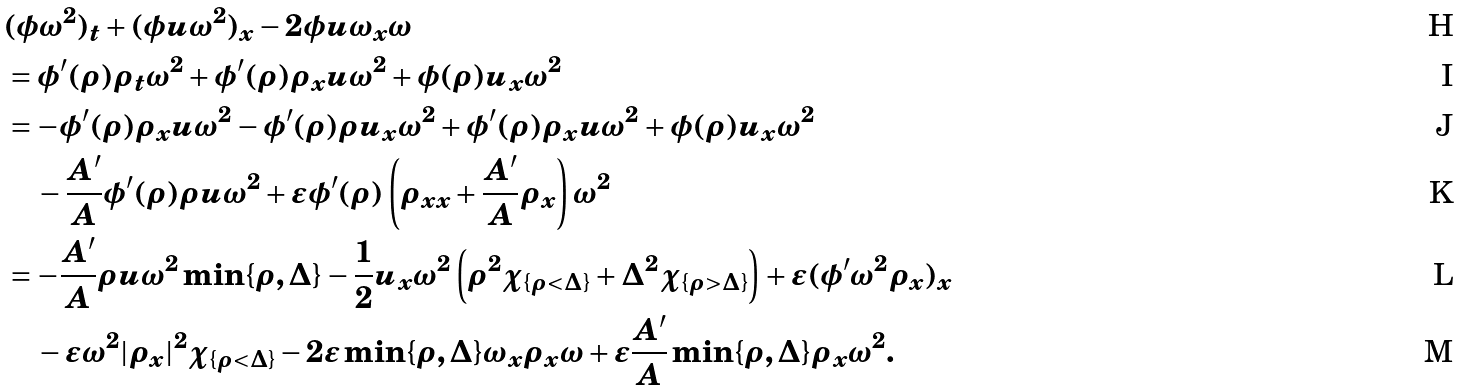<formula> <loc_0><loc_0><loc_500><loc_500>& ( \phi \omega ^ { 2 } ) _ { t } + ( \phi u \omega ^ { 2 } ) _ { x } - 2 \phi u \omega _ { x } \omega \\ & = \phi ^ { \prime } ( \rho ) \rho _ { t } \omega ^ { 2 } + \phi ^ { \prime } ( \rho ) \rho _ { x } u \omega ^ { 2 } + \phi ( \rho ) u _ { x } \omega ^ { 2 } \\ & = - \phi ^ { \prime } ( \rho ) \rho _ { x } u \omega ^ { 2 } - \phi ^ { \prime } ( \rho ) \rho u _ { x } \omega ^ { 2 } + \phi ^ { \prime } ( \rho ) \rho _ { x } u \omega ^ { 2 } + \phi ( \rho ) u _ { x } \omega ^ { 2 } \\ & \quad - \frac { A ^ { \prime } } { A } \phi ^ { \prime } ( \rho ) \rho u \omega ^ { 2 } + \varepsilon \phi ^ { \prime } ( \rho ) \left ( \rho _ { x x } + \frac { A ^ { \prime } } { A } \rho _ { x } \right ) \omega ^ { 2 } \\ & = - \frac { A ^ { \prime } } { A } \rho u \omega ^ { 2 } \min \{ \rho , \Delta \} - \frac { 1 } { 2 } u _ { x } \omega ^ { 2 } \left ( \rho ^ { 2 } \chi _ { \{ \rho < \Delta \} } + \Delta ^ { 2 } \chi _ { \{ \rho > \Delta \} } \right ) + \varepsilon ( \phi ^ { \prime } \omega ^ { 2 } \rho _ { x } ) _ { x } \\ & \quad - \varepsilon \omega ^ { 2 } | \rho _ { x } | ^ { 2 } \chi _ { \{ \rho < \Delta \} } - 2 \varepsilon \min \{ \rho , \Delta \} \omega _ { x } \rho _ { x } \omega + \varepsilon \frac { A ^ { \prime } } { A } \min \{ \rho , \Delta \} \rho _ { x } \omega ^ { 2 } .</formula> 